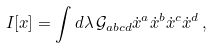Convert formula to latex. <formula><loc_0><loc_0><loc_500><loc_500>I [ x ] = \int d \lambda \, \mathcal { G } _ { a b c d } \dot { x } ^ { a } \dot { x } ^ { b } \dot { x } ^ { c } \dot { x } ^ { d } \, ,</formula> 